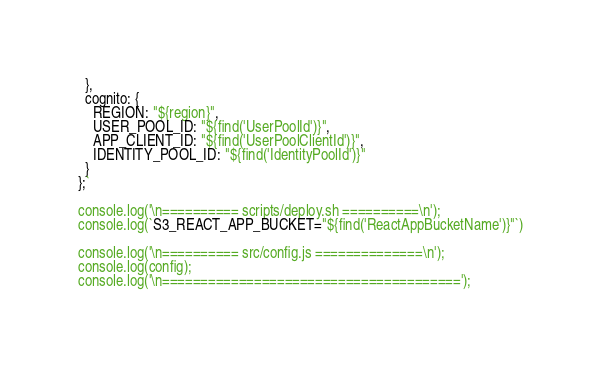Convert code to text. <code><loc_0><loc_0><loc_500><loc_500><_JavaScript_>  },
  cognito: {
    REGION: "${region}",
    USER_POOL_ID: "${find('UserPoolId')}",
    APP_CLIENT_ID: "${find('UserPoolClientId')}",
    IDENTITY_POOL_ID: "${find('IdentityPoolId')}"
  }
};`

console.log('\n========== scripts/deploy.sh ==========\n');
console.log(`S3_REACT_APP_BUCKET="${find('ReactAppBucketName')}"`)

console.log('\n========== src/config.js ==============\n');
console.log(config);
console.log('\n=======================================');
</code> 